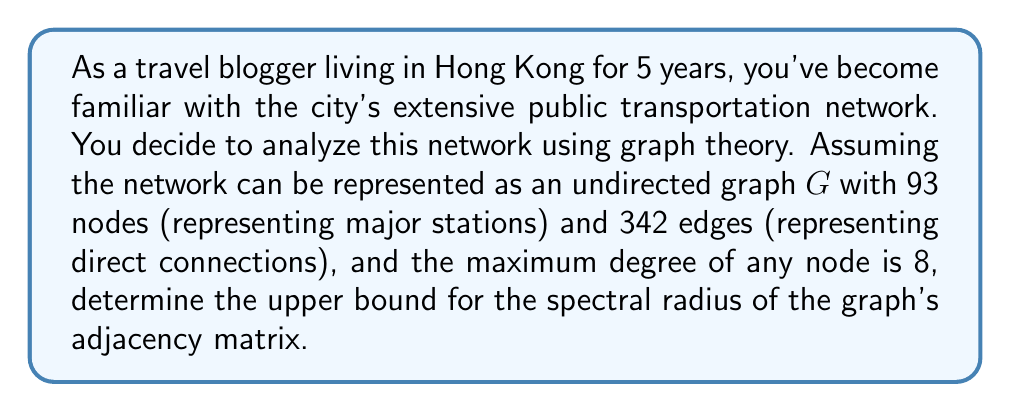Teach me how to tackle this problem. To solve this problem, we'll follow these steps:

1) Recall that for an undirected graph, the spectral radius $\rho(A)$ of its adjacency matrix A is bounded by:

   $$\rho(A) \leq \max\{\sqrt{d_id_j} : (i,j) \in E(G)\}$$

   where $d_i$ and $d_j$ are the degrees of vertices i and j, respectively, and E(G) is the edge set of G.

2) We're given that the maximum degree of any node is 8. Therefore, for any edge $(i,j)$:

   $$d_i \leq 8 \text{ and } d_j \leq 8$$

3) The maximum possible value for $\sqrt{d_id_j}$ occurs when both $d_i$ and $d_j$ are at their maximum:

   $$\max\{\sqrt{d_id_j}\} = \sqrt{8 \cdot 8} = \sqrt{64} = 8$$

4) Therefore, an upper bound for the spectral radius is:

   $$\rho(A) \leq 8$$

5) Note that this is a conservative upper bound. The actual spectral radius could be lower, depending on the specific structure of the graph.
Answer: $8$ 